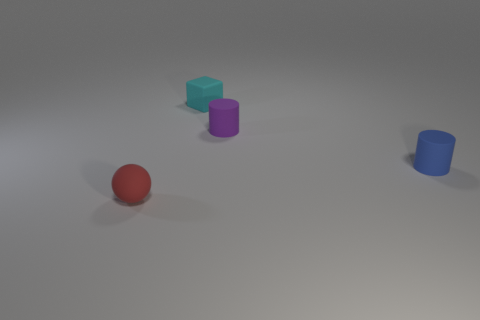The other rubber thing that is the same shape as the tiny purple rubber object is what size?
Offer a terse response. Small. Are there any tiny spheres behind the blue matte cylinder?
Give a very brief answer. No. Are there an equal number of cyan matte objects that are behind the matte cube and purple cylinders?
Your response must be concise. No. Is there a small red object that is to the right of the small rubber cylinder that is on the right side of the tiny matte cylinder that is to the left of the small blue cylinder?
Your answer should be very brief. No. What material is the tiny cube?
Your answer should be compact. Rubber. What number of other things are the same shape as the blue object?
Make the answer very short. 1. Does the red matte thing have the same shape as the blue thing?
Make the answer very short. No. What number of things are matte objects that are on the left side of the cube or small matte cylinders behind the blue matte object?
Provide a succinct answer. 2. What number of objects are small cyan cubes or small yellow matte cubes?
Keep it short and to the point. 1. There is a small rubber cylinder in front of the purple cylinder; how many tiny blue matte cylinders are on the left side of it?
Your answer should be very brief. 0. 